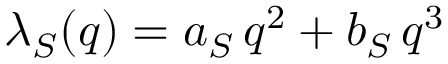<formula> <loc_0><loc_0><loc_500><loc_500>\lambda _ { S } ( q ) = a _ { S } \, q ^ { 2 } + b _ { S } \, q ^ { 3 }</formula> 